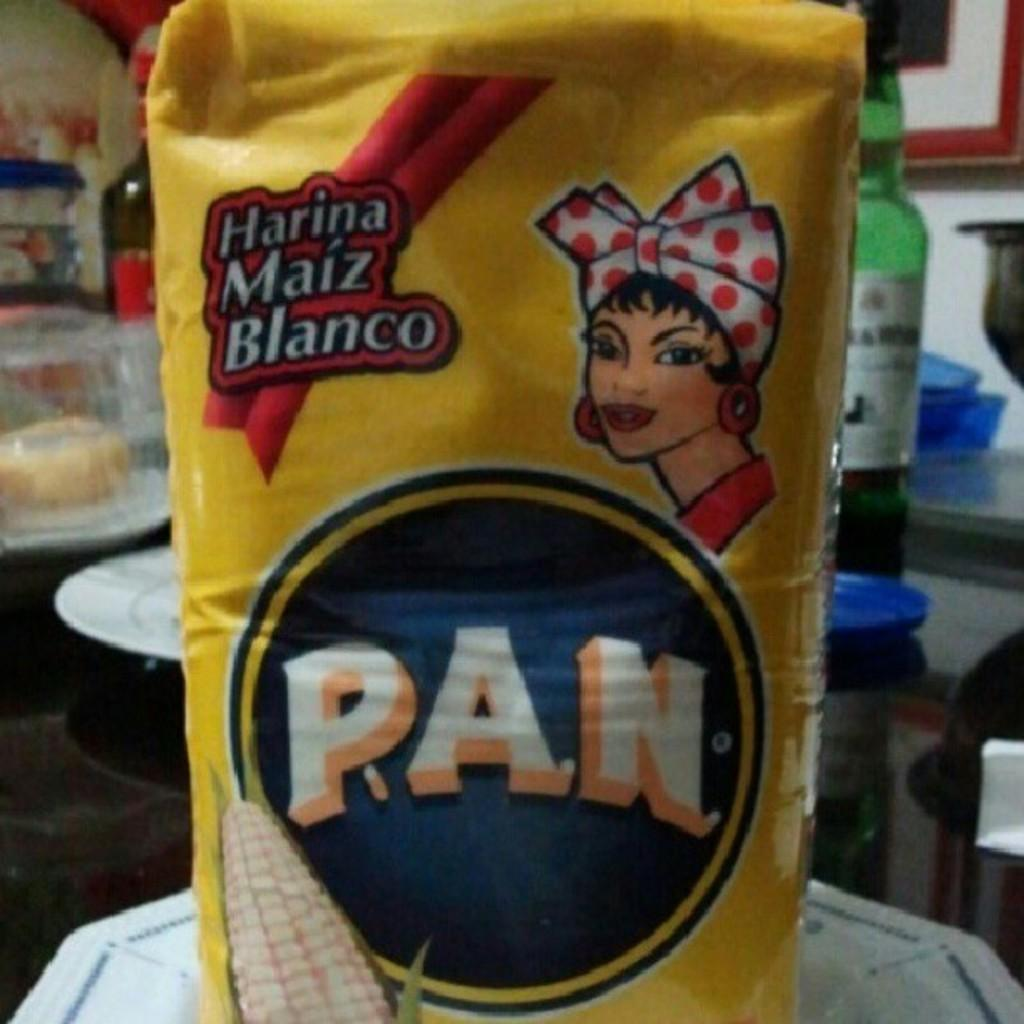<image>
Offer a succinct explanation of the picture presented. A yellow bag of P.A.N. corn flower sits on a white plate. 